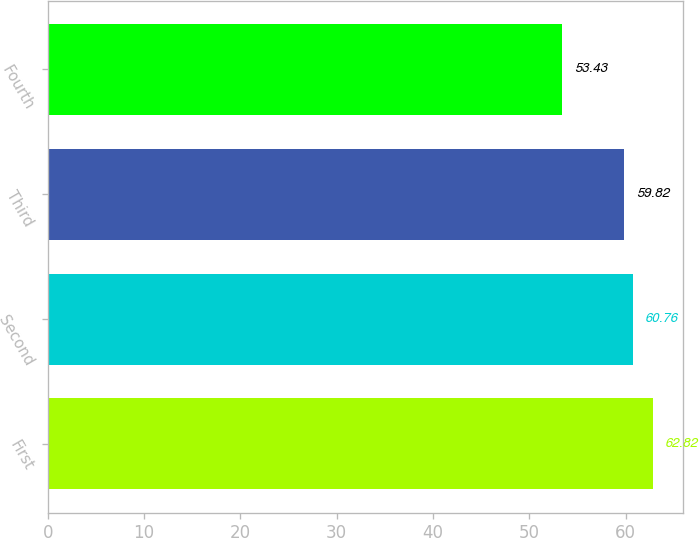<chart> <loc_0><loc_0><loc_500><loc_500><bar_chart><fcel>First<fcel>Second<fcel>Third<fcel>Fourth<nl><fcel>62.82<fcel>60.76<fcel>59.82<fcel>53.43<nl></chart> 